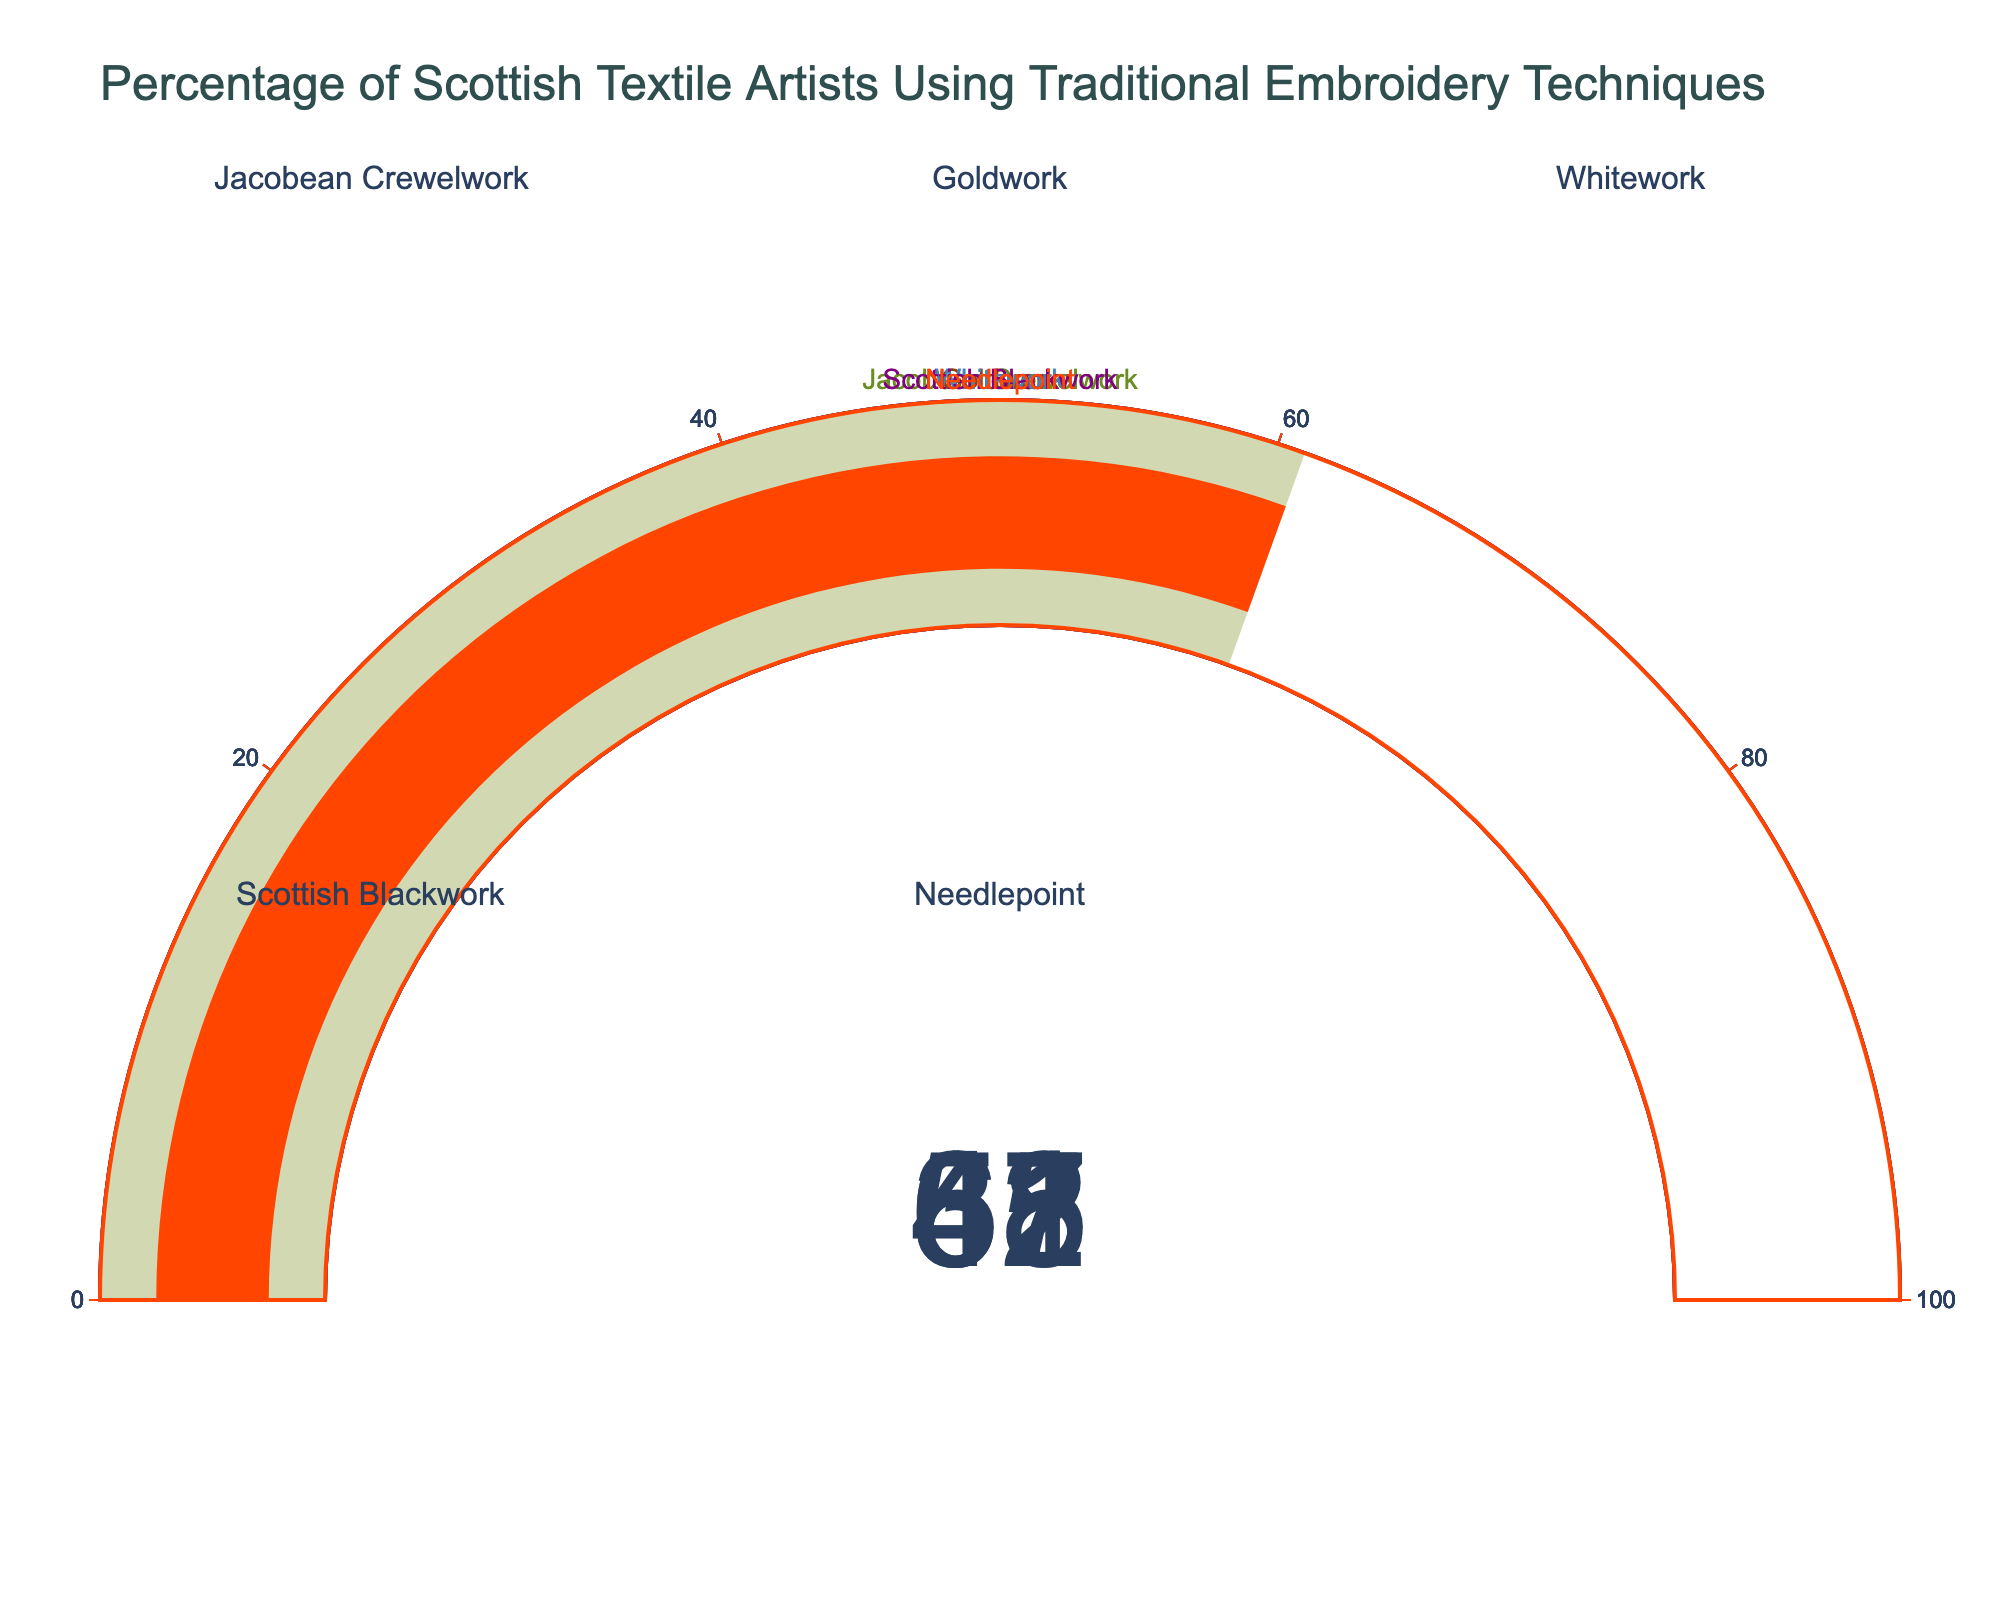What is the title of the figure? At the top of the figure, the title reads "Percentage of Scottish Textile Artists Using Traditional Embroidery Techniques". So, the title is simply the text displayed at the top.
Answer: Percentage of Scottish Textile Artists Using Traditional Embroidery Techniques How many different embroidery techniques are shown in the figure? Each gauge represents one embroidery technique, and there are a total of five gauges.
Answer: Five Which traditional embroidery technique has the highest percentage of use among Scottish textile artists? By looking at the values presented on each gauge, the highest percentage is 68% for Jacobean Crewelwork.
Answer: Jacobean Crewelwork What is the color used to represent the Jacobean Crewelwork technique in the figure? The gauge for Jacobean Crewelwork is colored in a distinct olive-green shade.
Answer: Olive-green What is the range of percentages depicted on each gauge? Each gauge's scale ranges from 0 to 100, indicating the percentage of artists using each technique.
Answer: 0 to 100 What is the median percentage value of all the presented techniques? To find the median, first list the percentages in ascending order: 37, 42, 55, 61, 68. The middle value is 55.
Answer: 55 What is the total percentage value when combining the use of Needlepoint and Goldwork techniques? The Needlepoint gauge shows 61%, and the Goldwork gauge shows 42%. Adding these gives 61 + 42 = 103.
Answer: 103 Which technique has a lower percentage use than Whitework but higher than Scottish Blackwork? Whitework has 55%, and Scottish Blackwork has 37%. Goldwork, at 42%, fits this criterion.
Answer: Goldwork Is the percentage of artists using Needlepoint higher or lower than the median value of all presented techniques? The median value is 55%. The Needlepoint gauge shows 61%, which is higher than the median.
Answer: Higher Considering the displayed gauges, what is the average percentage use of the five embroidery techniques? Summing the percentages gives 68 + 42 + 55 + 37 + 61 = 263. Dividing by 5, the average is 263 / 5 = 52.6.
Answer: 52.6 